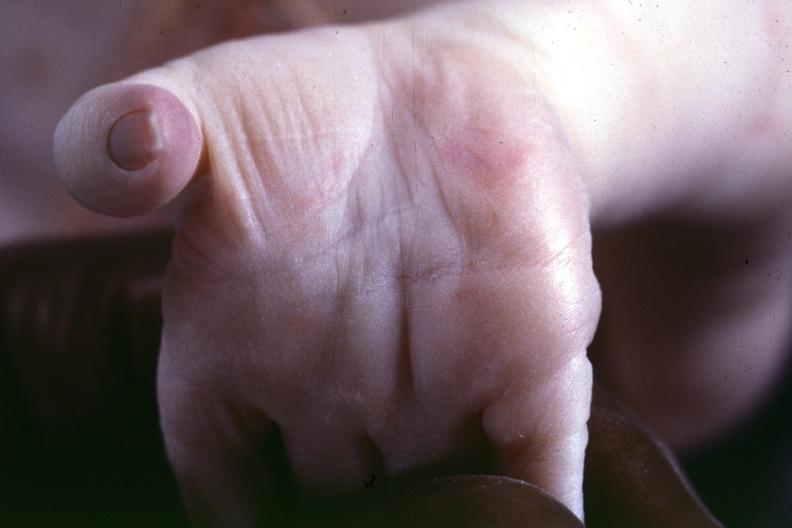what are present?
Answer the question using a single word or phrase. Extremities 